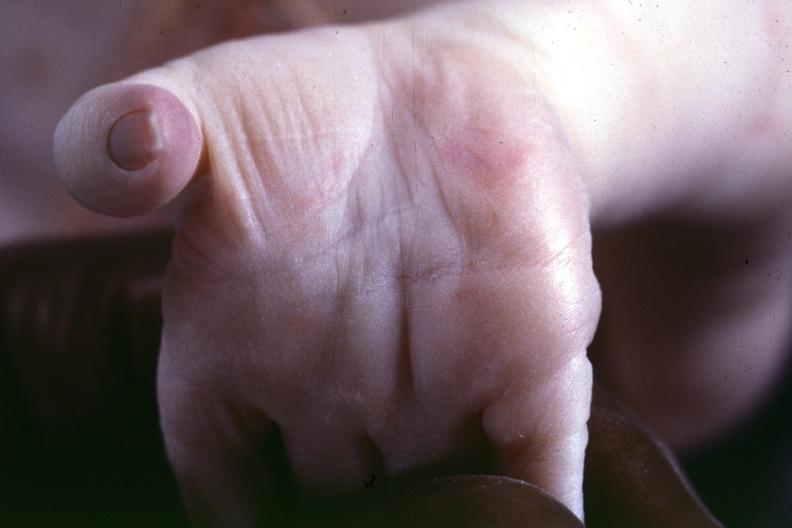what are present?
Answer the question using a single word or phrase. Extremities 